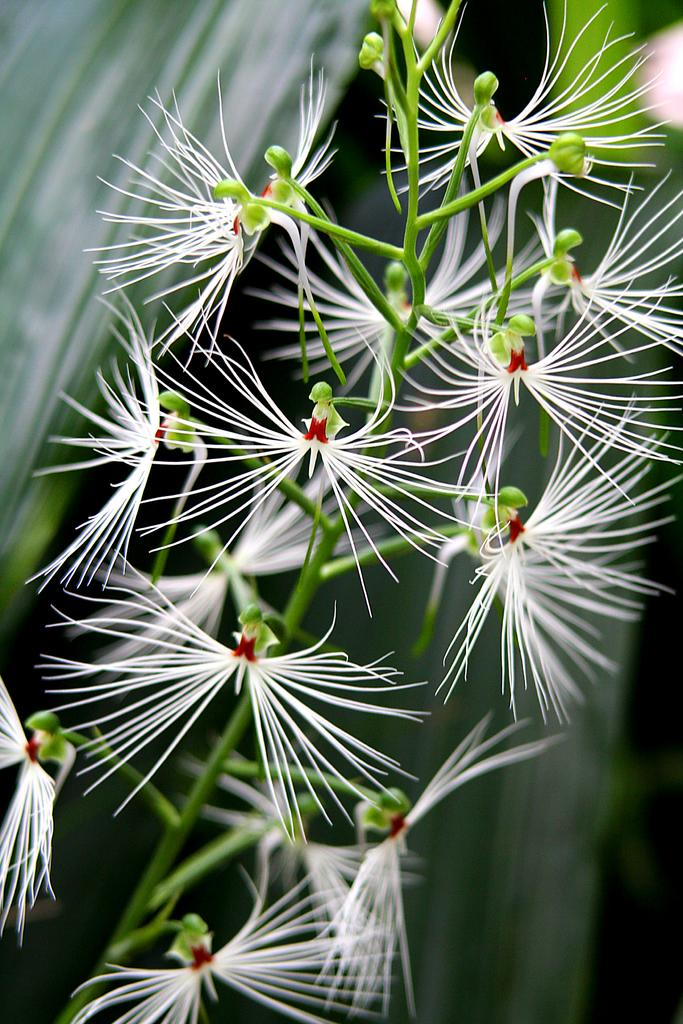What type of living organisms can be seen in the image? There are flowers in the image. Can you describe the background of the image? The background of the image is blurry. How many boys are visible in the image? There are no boys present in the image; it features flowers and a blurry background. What time of day is it in the image? The time of day is not mentioned or depicted in the image, so it cannot be determined. 